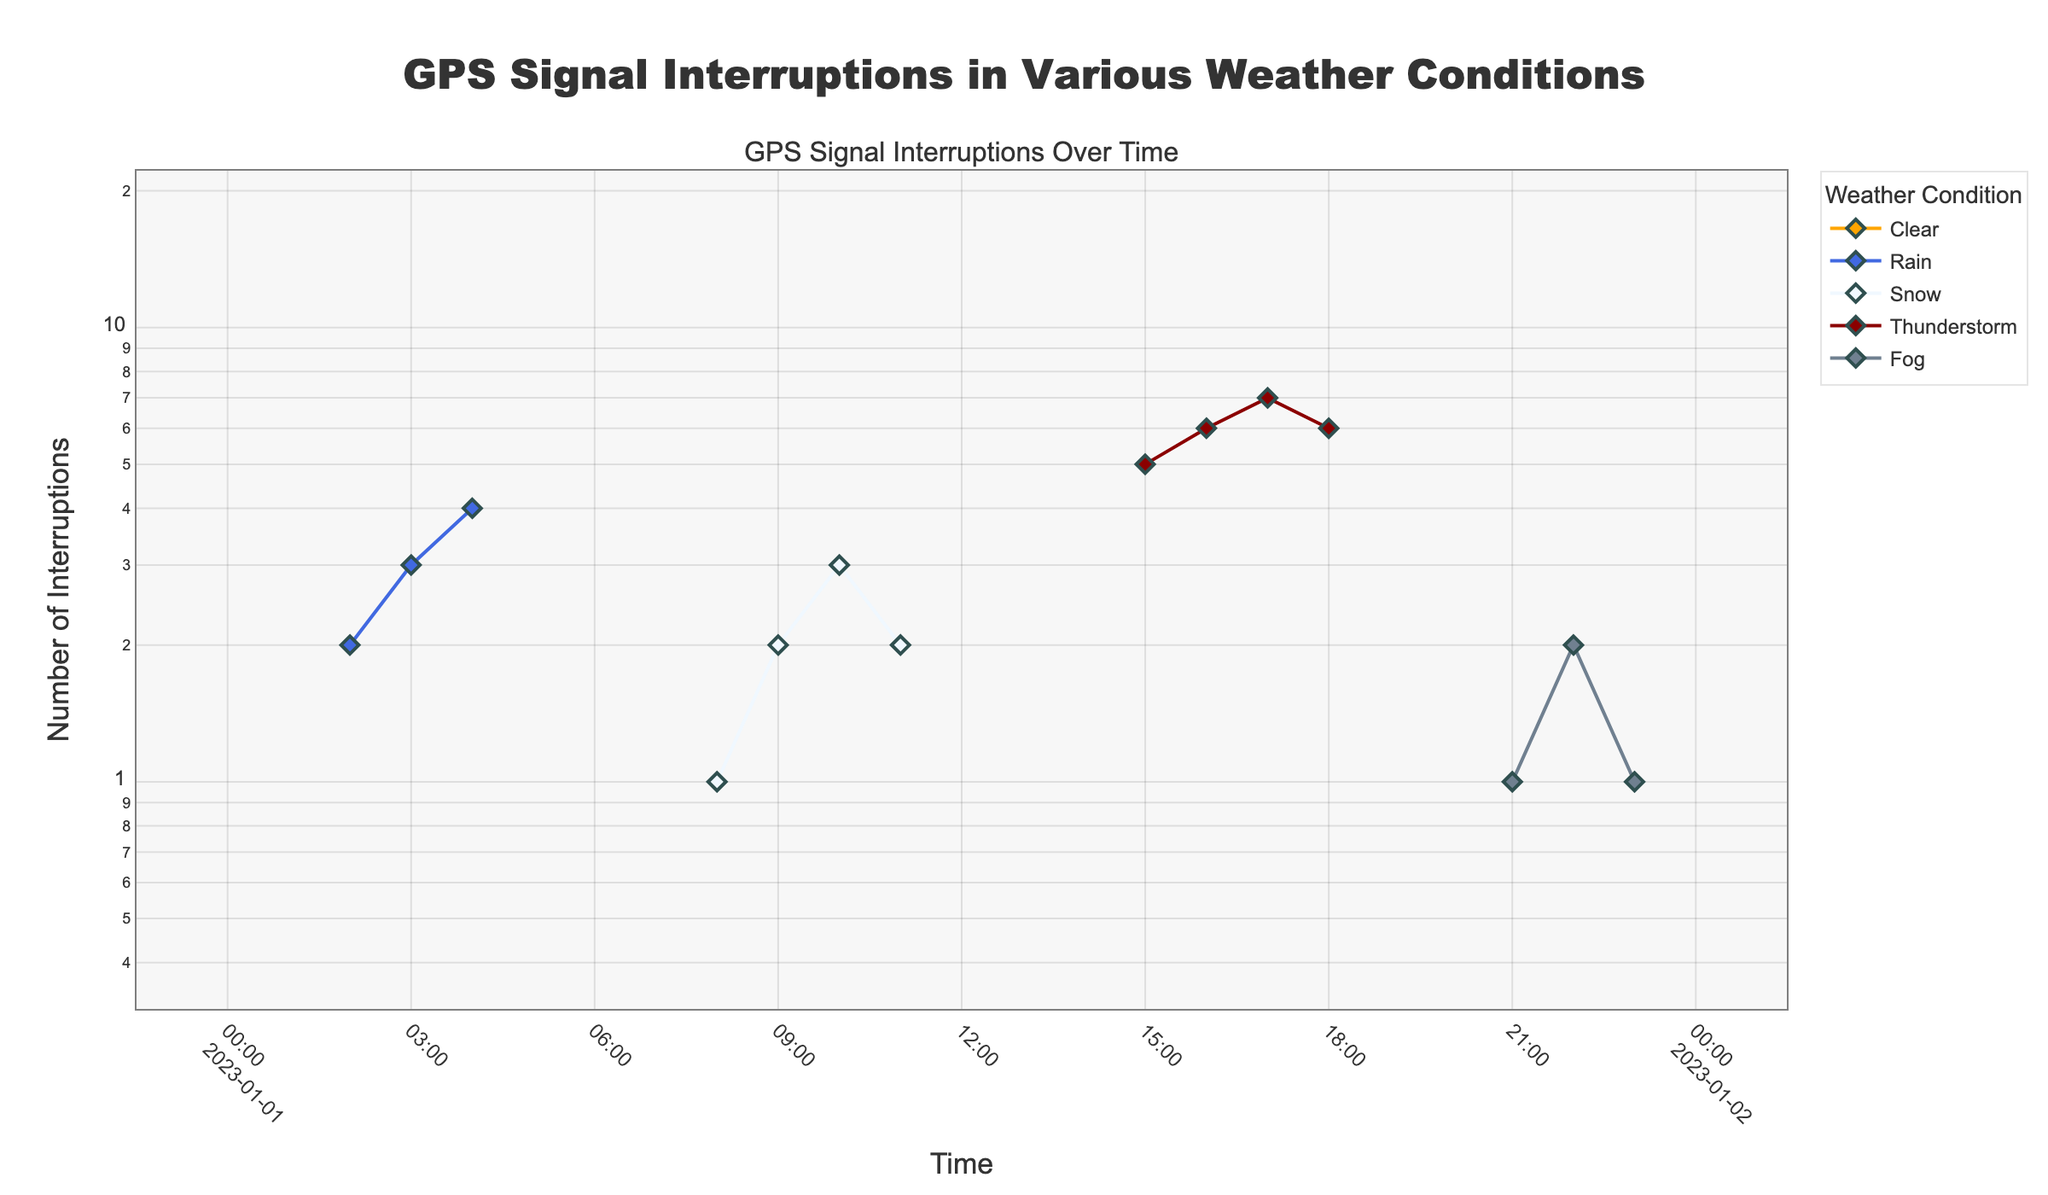what is the title of the plot? The title is located at the top of the plot, usually in a larger font and distinct from other text elements for emphasis. It reads "GPS Signal Interruptions in Various Weather Conditions" indicating the focus of the plot is on GPS interruptions related to different weather types.
Answer: GPS Signal Interruptions in Various Weather Conditions How are the GPS signal interruptions during 'Clear' weather conditions represented visually? In the plot, the 'Clear' weather conditions are represented with orange lines and diamond markers. This color and shape differentiates this data from other weather conditions.
Answer: Orange lines and diamond markers How many 'Thunderstorm' data points show interruptions? To find the number of 'Thunderstorm' interruptions, identify the sections of the plot with red lines and count the markers which are diamond shapes associated with 'Thunderstorm'. There are interruptions at hours 15, 16, 17, and 18.
Answer: 4 What weather condition has the highest recorded interruptions and what is its value? By examining the plot, look for the highest point on the y-axis regardless of the color. The tallest point occurs in 'Thunderstorm' conditions with an interruption value of 7.
Answer: Thunderstorm with 7 interruptions How do GPS interruptions vary between 03:00 to 06:00? From 03:00 to 06:00, the plot shows blue lines (representing 'Rain' weather) transitioning to orange lines (representing 'Clear' weather) with interruption values dropping from 4 to 0. This indicates a higher number of interruptions during rainy conditions and none in clear weather.
Answer: Decrease from Rain with 4 interruptions to Clear with 0 Which weather conditions do not show any interruptions, and at what times do these occur? Identify sections of the plot with markers at the 0 interruption level. Orange lines with diamond markers are seen at 00:00, 01:00, 05:00, 06:00, 07:00, 12:00, 13:00, 14:00, 19:00, and 20:00. These times correspond to the 'Clear' weather condition.
Answer: Clear at 00:00, 01:00, 05:00, 06:00, 07:00, 12:00, 13:00, 14:00, 19:00, and 20:00 Compare the number of interruptions in 'Rain' between 03:00 and 05:00 to 'Snow' between 08:00 and 11:00. Calculate the interruption counts during specified periods: 'Rain' between 03:00 and 05:00 shows interruptions of 3 and 4, totaling 9. 'Snow' between 08:00 and 11:00 has interruptions of 1, 2, 3, and 2, totaling 8, making 'Rain' 1 interruption higher.
Answer: Rain has 1 more interruption What is the trend of interruptions in 'Fog' weather conditions throughout the sampled period? Locate the gray lines with diamond markers representing 'Fog' at specific times. There are 3 interruptions at 21:00, 22:00, and 23:00 with values of 1, 2, 1 respectively, indicating a small increase and then stabilization.
Answer: Increase to 2 and then stabilize at 1 How does the log scale affect the visual representation of the interruption data? A log scale transforms the y-axis to display orders of magnitude, making the differences between low and high values more pronounced. For interruptions close to 0 or 1, changes are more apparent, aiding in interpreting smaller values among large ones effectively.
Answer: Makes differences between small values more apparent 